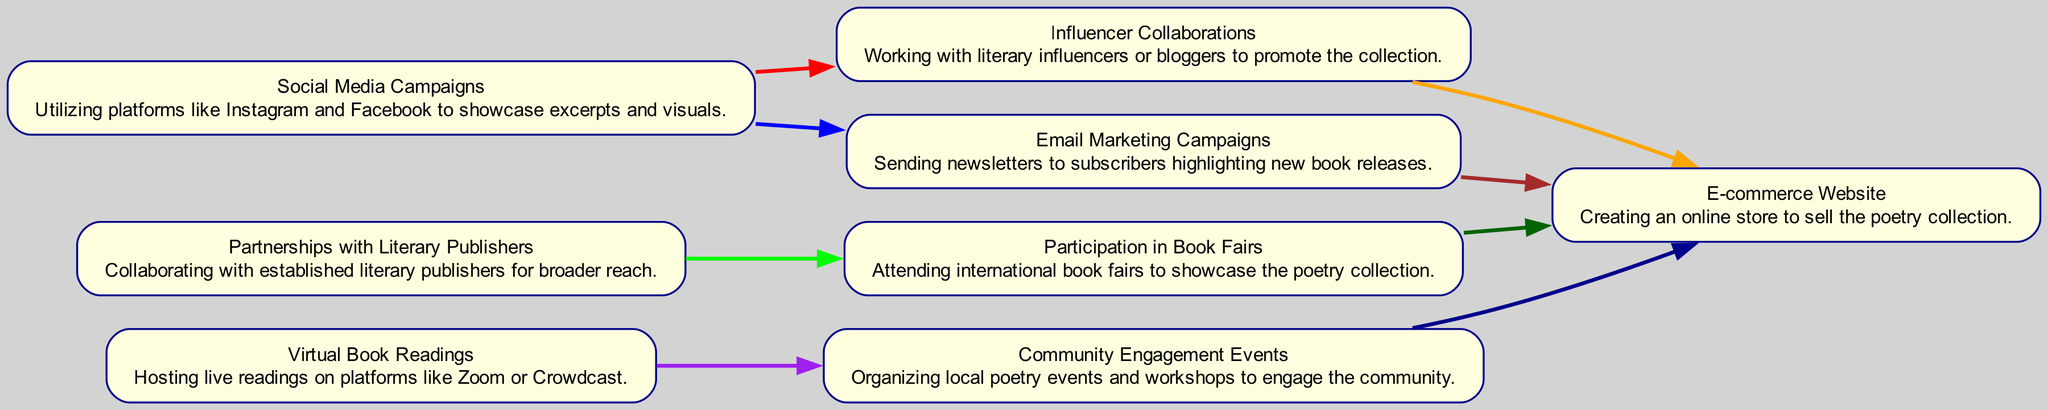What are the total number of nodes in the diagram? By counting each unique element in the diagram section under "elements," we find there are 8 nodes in total, representing different marketing strategies and channels.
Answer: 8 What marketing strategy is directly linked to both Social Media Campaigns and Email Marketing Campaigns? The node connected to both Social Media Campaigns and Email Marketing Campaigns is Online Store. Both edges lead directly to this node, indicating that both strategies contribute to promoting the online store.
Answer: Online Store Which marketing strategy connects to the Virtual Book Readings? The strategy directly connected to Virtual Book Readings is Local Events, as there is a directed edge leading from Book Readings to Local Events in the diagram.
Answer: Local Events How many edges are there leading into the Online Store? By examining the diagram, we see that there are four directed edges leading to Online Store, as it receives connections from Influencer Marketing, Email Marketing, Book Fairs, and Local Events.
Answer: 4 What is the primary color of the edge connecting Social Media Campaigns to Influencer Collaborations? The edge connecting Social Media Campaigns to Influencer Collaborations is colored red, as indicated by the color attributes of the edge in the diagram.
Answer: Red What two strategies contribute to the promotion of the E-commerce Website? The two strategies that contribute to promoting the E-commerce Website are Influencer Collaborations and Email Marketing Campaigns, as both have directed edges pointing towards the Online Store node.
Answer: Influencer Collaborations; Email Marketing Campaigns Which node has outgoing edges but no incoming edges? The Partnerships with Literary Publishers node has outgoing edges to the Participation in Book Fairs node but no arrows pointing back to it, indicating it only promotes the other strategy.
Answer: Partnerships with Literary Publishers Which node serves as a common link between Literary Publishers and Online Store? The Book Fairs node serves as a common link, with a directed edge pointing from Literary Publishers to Book Fairs and another edge pointing from Book Fairs to Online Store.
Answer: Book Fairs What is the overall theme depicted in the diagram? By analyzing the nodes and the connections, the overall theme highlights marketing channels and strategies tailored for promoting a collection of Ukrainian poetry through engagement and visibility.
Answer: Marketing channels for promoting poetry collection 